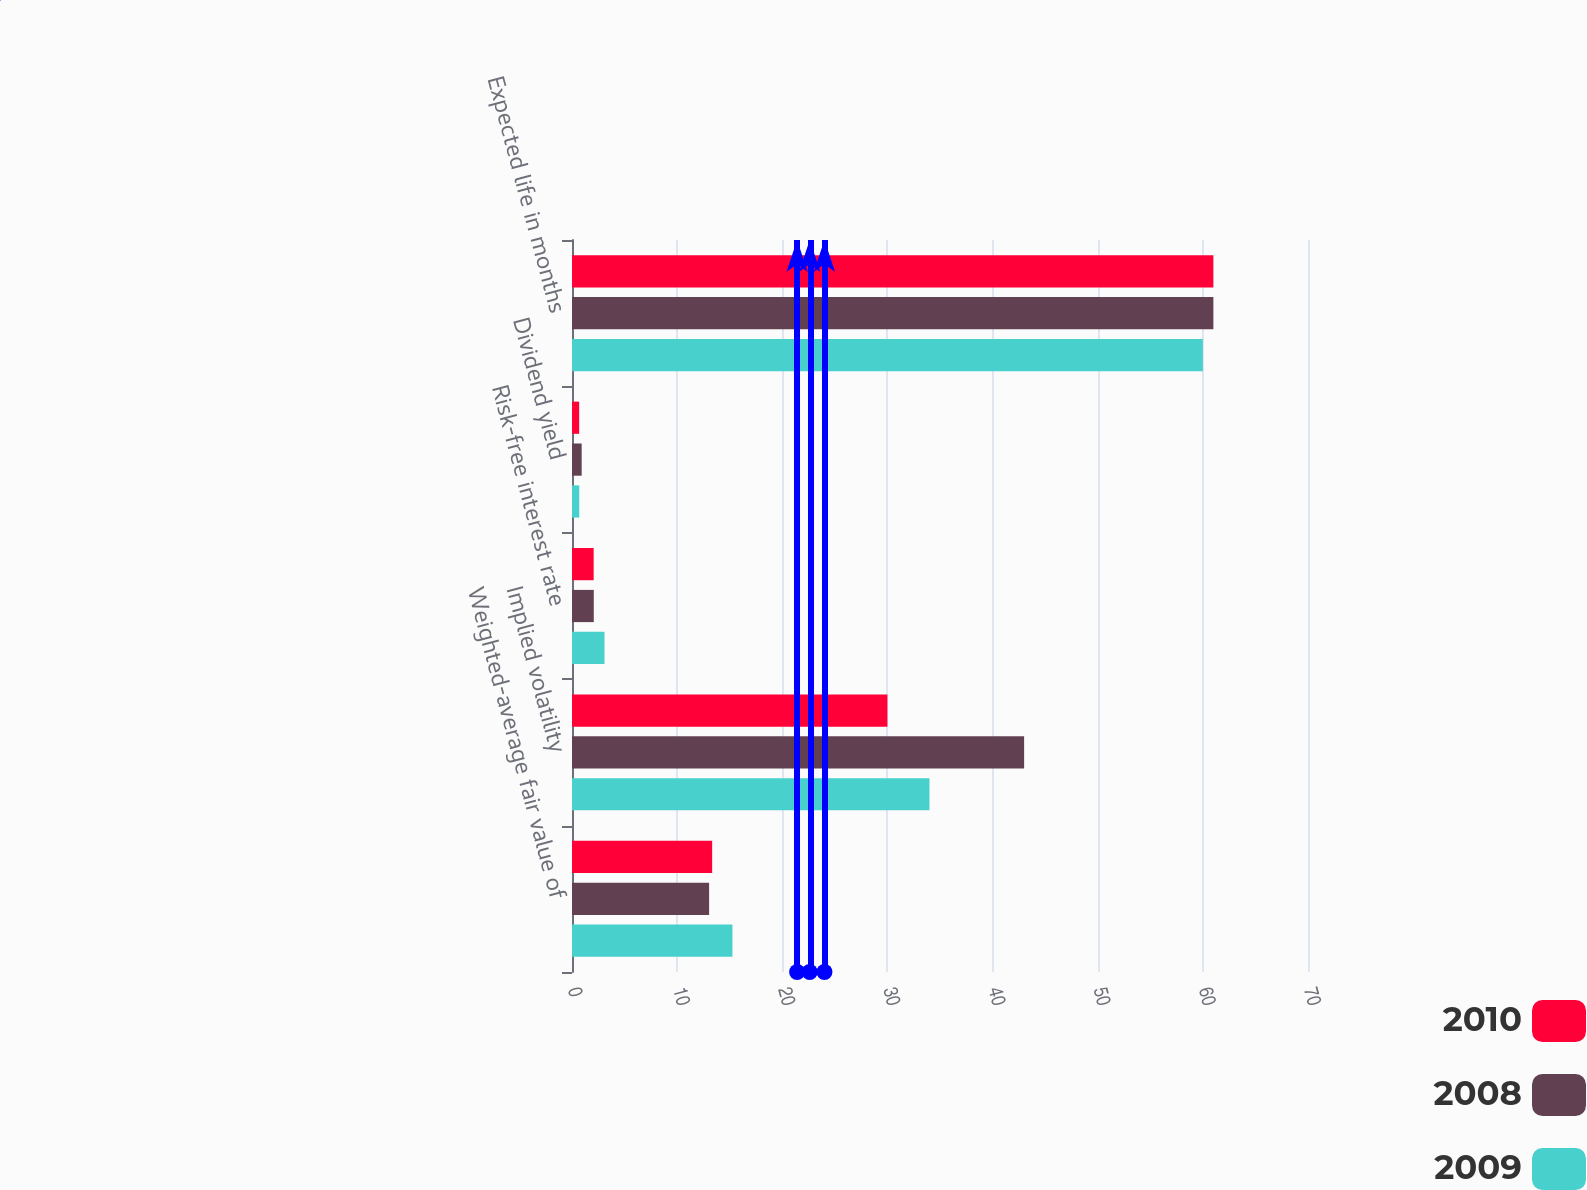Convert chart to OTSL. <chart><loc_0><loc_0><loc_500><loc_500><stacked_bar_chart><ecel><fcel>Weighted-average fair value of<fcel>Implied volatility<fcel>Risk-free interest rate<fcel>Dividend yield<fcel>Expected life in months<nl><fcel>2010<fcel>13.33<fcel>30<fcel>2.06<fcel>0.68<fcel>61<nl><fcel>2008<fcel>13.04<fcel>43<fcel>2.07<fcel>0.92<fcel>61<nl><fcel>2009<fcel>15.26<fcel>34<fcel>3.09<fcel>0.69<fcel>60<nl></chart> 